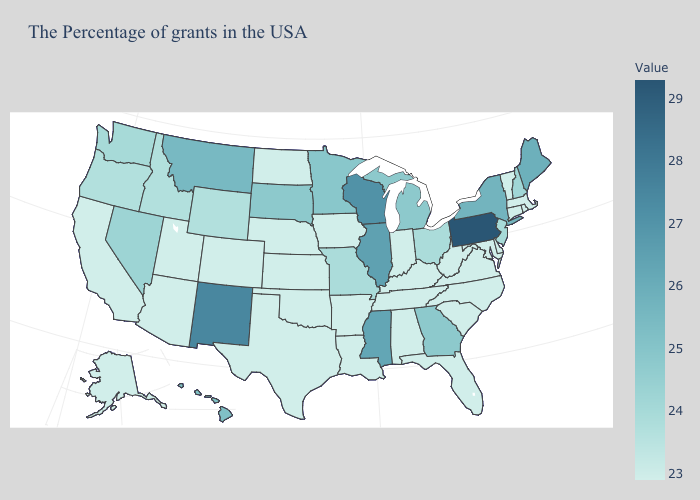Among the states that border California , which have the highest value?
Concise answer only. Nevada. Among the states that border Michigan , which have the lowest value?
Give a very brief answer. Indiana. Does Idaho have the highest value in the USA?
Give a very brief answer. No. Is the legend a continuous bar?
Answer briefly. Yes. 